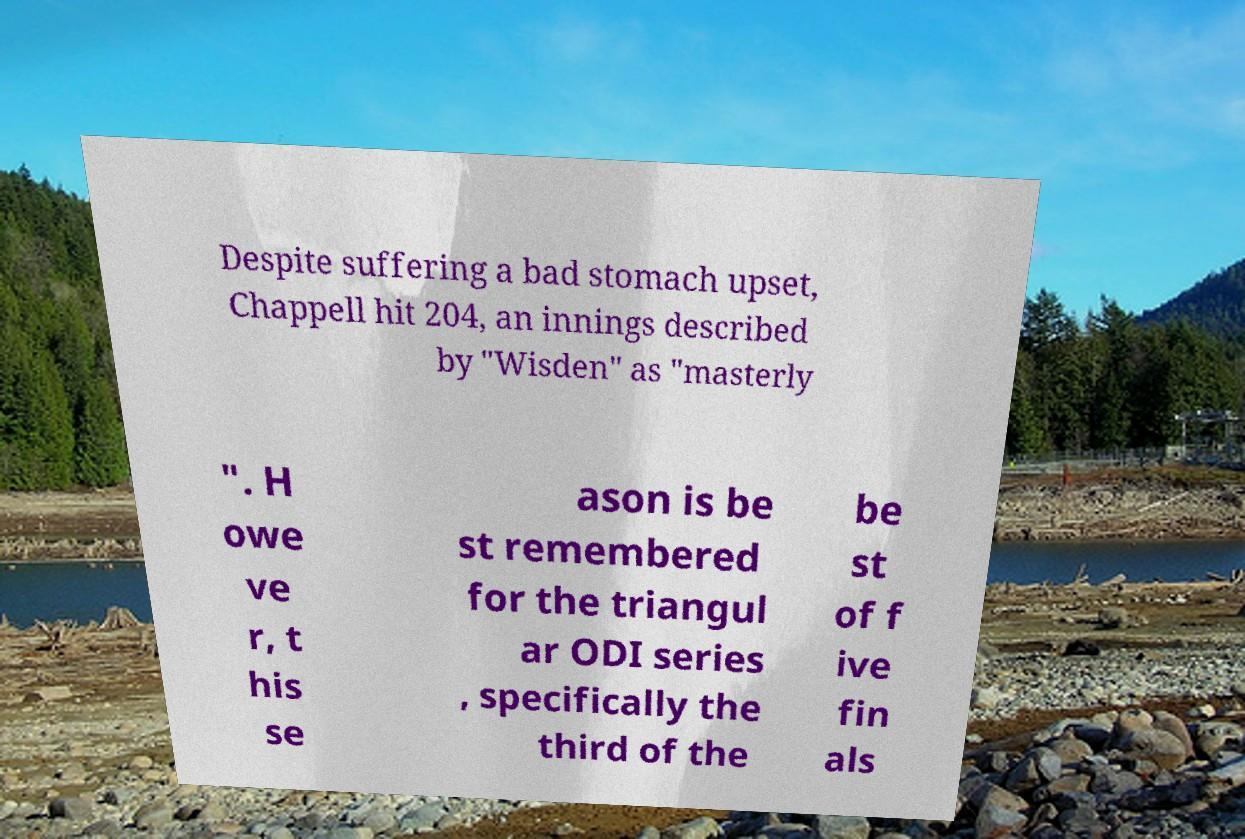What messages or text are displayed in this image? I need them in a readable, typed format. Despite suffering a bad stomach upset, Chappell hit 204, an innings described by "Wisden" as "masterly ". H owe ve r, t his se ason is be st remembered for the triangul ar ODI series , specifically the third of the be st of f ive fin als 